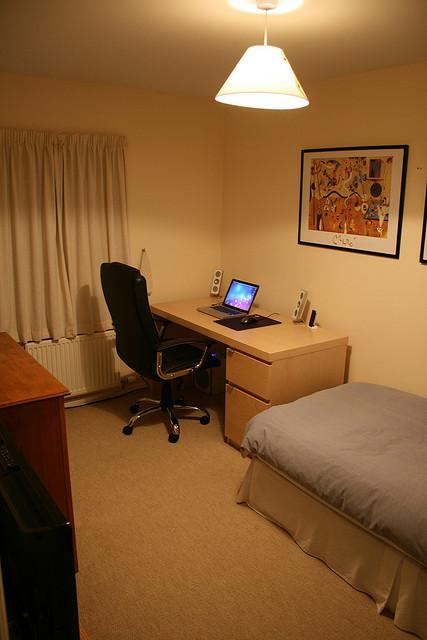How many chairs in the room?
Short answer required. 1. Which color is dominant?
Give a very brief answer. Tan. Is this a large room?
Write a very short answer. No. 